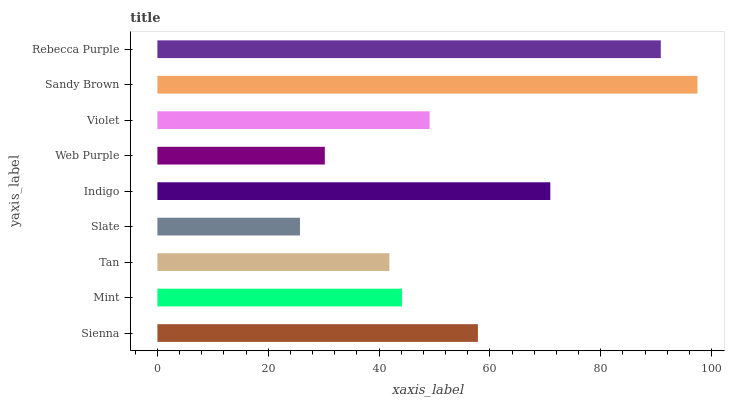Is Slate the minimum?
Answer yes or no. Yes. Is Sandy Brown the maximum?
Answer yes or no. Yes. Is Mint the minimum?
Answer yes or no. No. Is Mint the maximum?
Answer yes or no. No. Is Sienna greater than Mint?
Answer yes or no. Yes. Is Mint less than Sienna?
Answer yes or no. Yes. Is Mint greater than Sienna?
Answer yes or no. No. Is Sienna less than Mint?
Answer yes or no. No. Is Violet the high median?
Answer yes or no. Yes. Is Violet the low median?
Answer yes or no. Yes. Is Sandy Brown the high median?
Answer yes or no. No. Is Sandy Brown the low median?
Answer yes or no. No. 